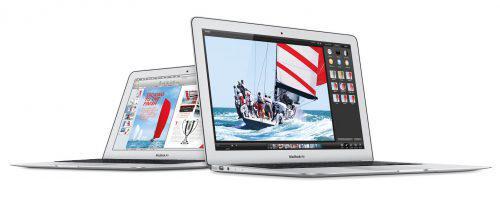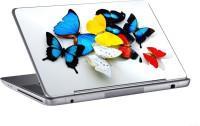The first image is the image on the left, the second image is the image on the right. Examine the images to the left and right. Is the description "The right image shows exactly one laptop with a picture on the back facing outward, and the left image includes at least two laptops that are at least partly open." accurate? Answer yes or no. Yes. The first image is the image on the left, the second image is the image on the right. For the images displayed, is the sentence "There are five open laptops with at least two turned away." factually correct? Answer yes or no. No. 